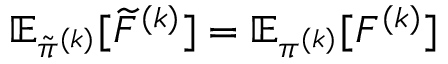Convert formula to latex. <formula><loc_0><loc_0><loc_500><loc_500>\mathbb { E } _ { \tilde { \pi } ^ { ( k ) } } [ \widetilde { F } ^ { ( k ) } ] = \mathbb { E } _ { \pi ^ { ( k ) } } [ F ^ { ( k ) } ]</formula> 